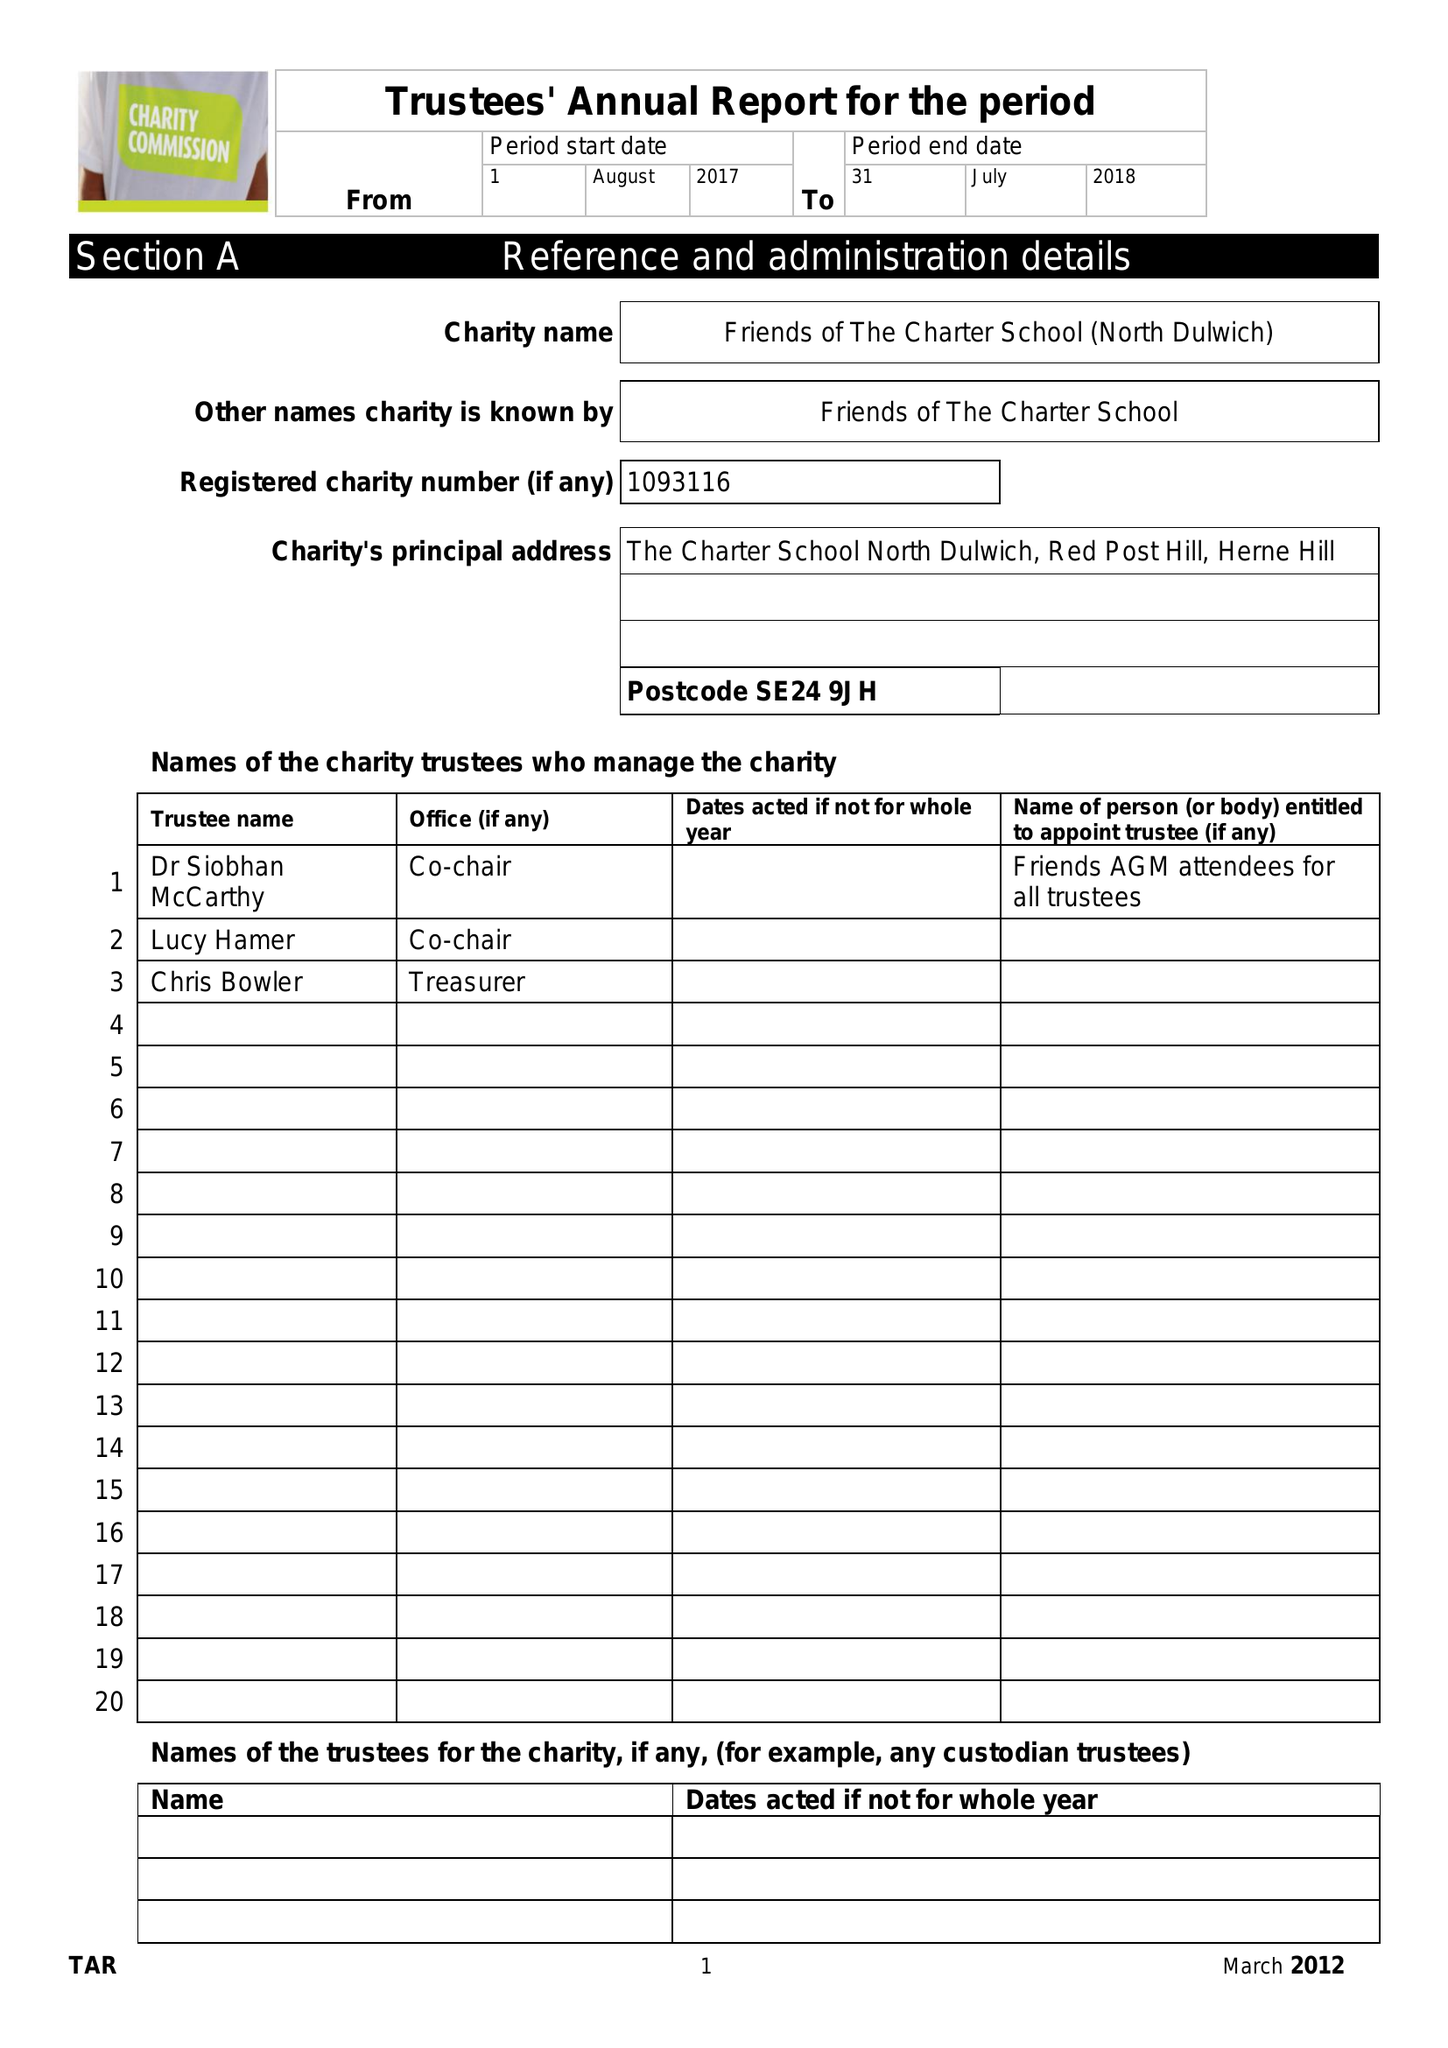What is the value for the spending_annually_in_british_pounds?
Answer the question using a single word or phrase. 24929.00 